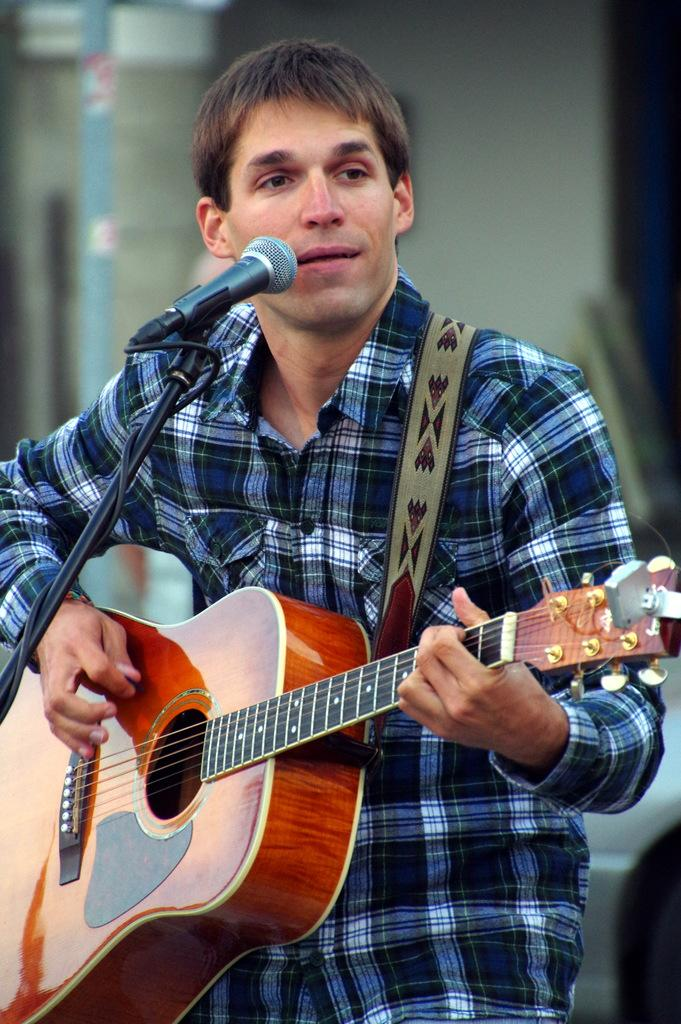What is the man in the image doing? The man is playing a guitar and singing. How is the man's voice being amplified in the image? The man is using a microphone. What type of tax is being discussed in the image? There is no discussion of tax in the image; it features a man playing a guitar, singing, and using a microphone. 